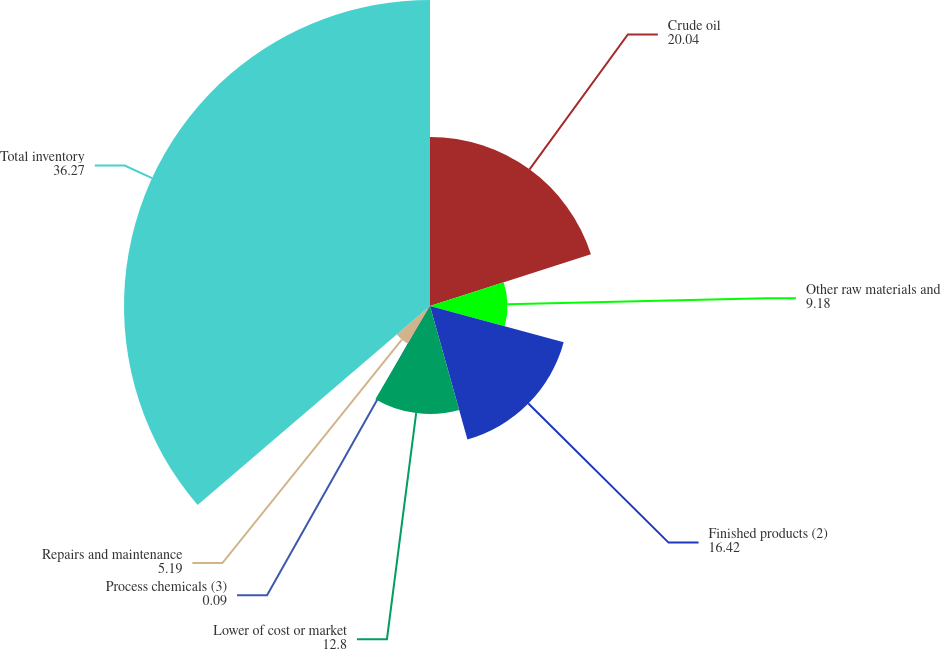Convert chart to OTSL. <chart><loc_0><loc_0><loc_500><loc_500><pie_chart><fcel>Crude oil<fcel>Other raw materials and<fcel>Finished products (2)<fcel>Lower of cost or market<fcel>Process chemicals (3)<fcel>Repairs and maintenance<fcel>Total inventory<nl><fcel>20.04%<fcel>9.18%<fcel>16.42%<fcel>12.8%<fcel>0.09%<fcel>5.19%<fcel>36.27%<nl></chart> 